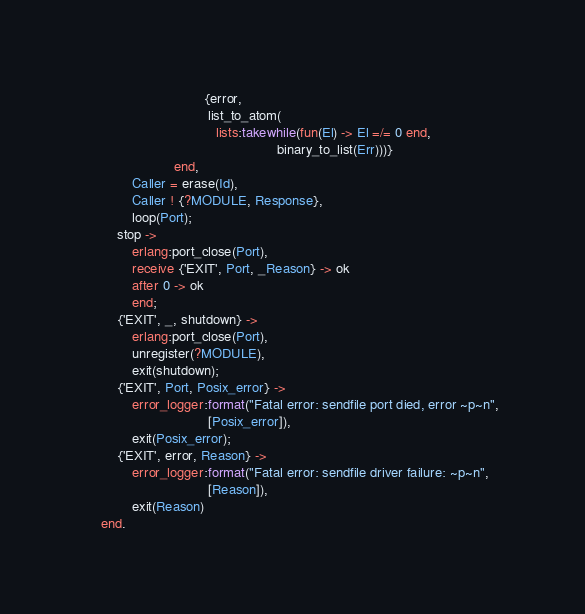<code> <loc_0><loc_0><loc_500><loc_500><_Erlang_>                               {error,
                                list_to_atom(
                                  lists:takewhile(fun(El) -> El =/= 0 end,
                                                  binary_to_list(Err)))}
                       end,
            Caller = erase(Id),
            Caller ! {?MODULE, Response},
            loop(Port);
        stop ->
            erlang:port_close(Port),
            receive {'EXIT', Port, _Reason} -> ok
            after 0 -> ok
            end;
        {'EXIT', _, shutdown} ->
            erlang:port_close(Port),
            unregister(?MODULE),
            exit(shutdown);
        {'EXIT', Port, Posix_error} ->
            error_logger:format("Fatal error: sendfile port died, error ~p~n",
                                [Posix_error]),
            exit(Posix_error);
        {'EXIT', error, Reason} ->
            error_logger:format("Fatal error: sendfile driver failure: ~p~n",
                                [Reason]),
            exit(Reason)
    end.
</code> 